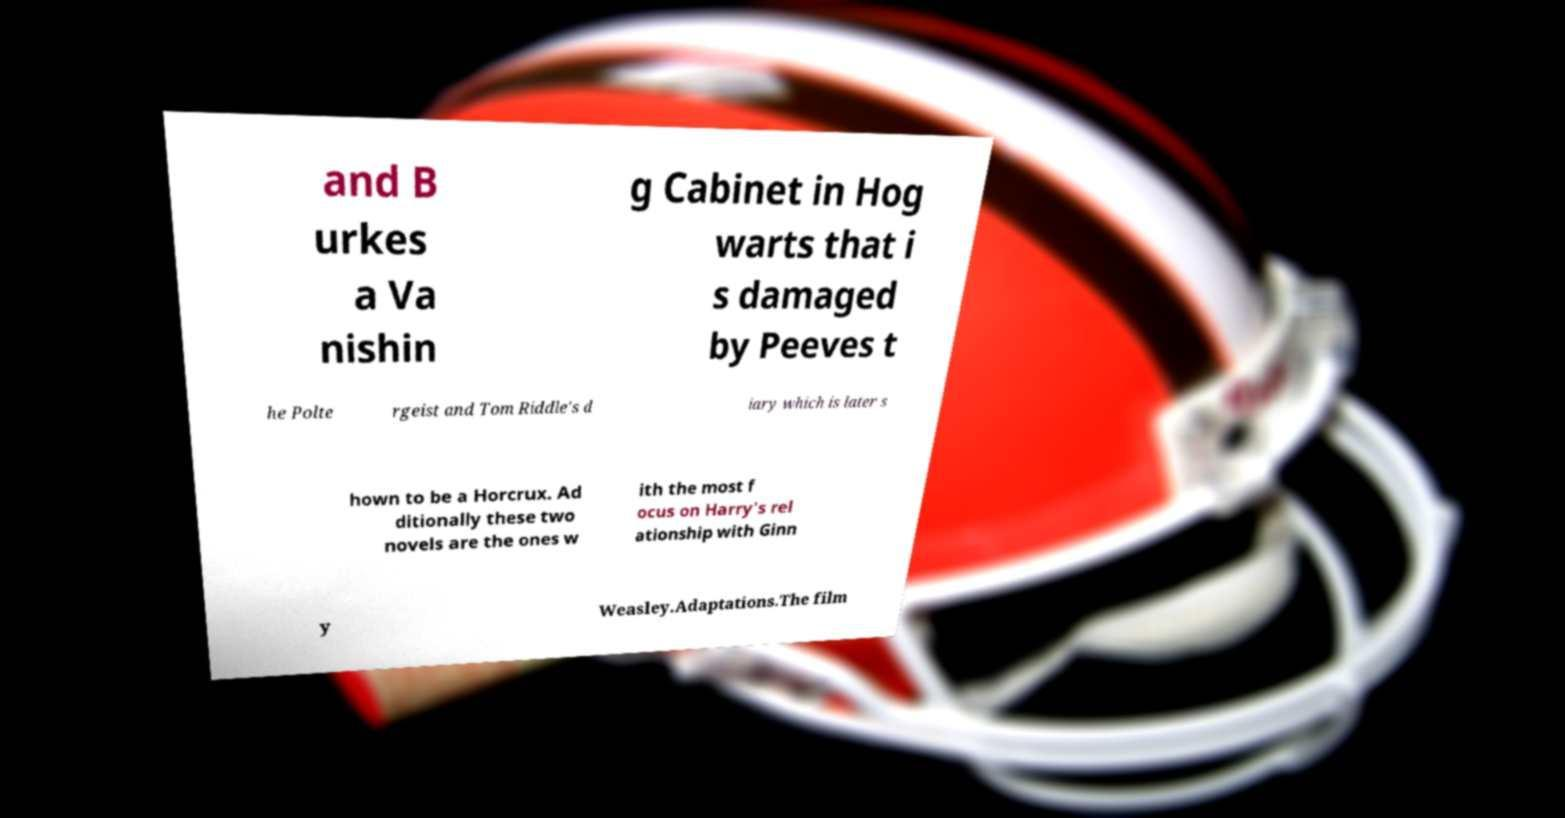For documentation purposes, I need the text within this image transcribed. Could you provide that? and B urkes a Va nishin g Cabinet in Hog warts that i s damaged by Peeves t he Polte rgeist and Tom Riddle's d iary which is later s hown to be a Horcrux. Ad ditionally these two novels are the ones w ith the most f ocus on Harry's rel ationship with Ginn y Weasley.Adaptations.The film 